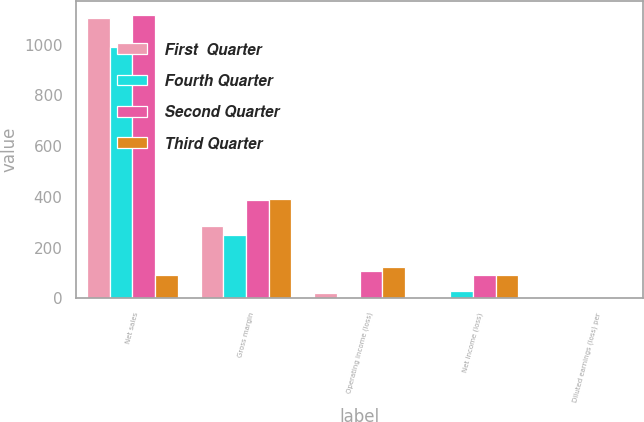Convert chart. <chart><loc_0><loc_0><loc_500><loc_500><stacked_bar_chart><ecel><fcel>Net sales<fcel>Gross margin<fcel>Operating income (loss)<fcel>Net income (loss)<fcel>Diluted earnings (loss) per<nl><fcel>First  Quarter<fcel>1107.2<fcel>286<fcel>21.7<fcel>1.1<fcel>0<nl><fcel>Fourth Quarter<fcel>991<fcel>248.2<fcel>7.1<fcel>28.3<fcel>0.04<nl><fcel>Second Quarter<fcel>1116.8<fcel>387.9<fcel>109.7<fcel>90.9<fcel>0.13<nl><fcel>Third Quarter<fcel>93.5<fcel>392.6<fcel>125.4<fcel>93.5<fcel>0.14<nl></chart> 